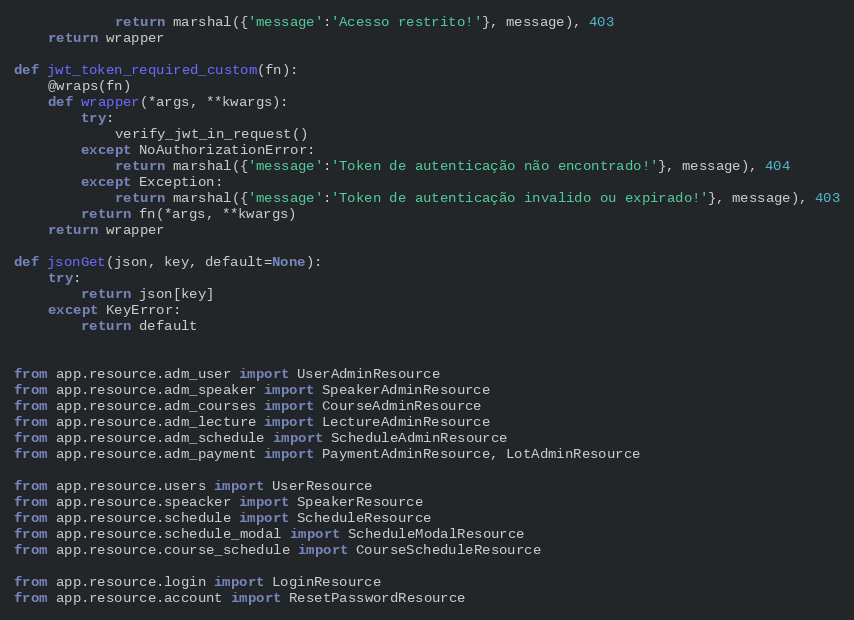<code> <loc_0><loc_0><loc_500><loc_500><_Python_>            return marshal({'message':'Acesso restrito!'}, message), 403
    return wrapper

def jwt_token_required_custom(fn):
    @wraps(fn)
    def wrapper(*args, **kwargs):
        try:
            verify_jwt_in_request()
        except NoAuthorizationError:
            return marshal({'message':'Token de autenticação não encontrado!'}, message), 404
        except Exception:
            return marshal({'message':'Token de autenticação invalido ou expirado!'}, message), 403
        return fn(*args, **kwargs)
    return wrapper

def jsonGet(json, key, default=None):
    try:
        return json[key]
    except KeyError:
        return default


from app.resource.adm_user import UserAdminResource
from app.resource.adm_speaker import SpeakerAdminResource
from app.resource.adm_courses import CourseAdminResource
from app.resource.adm_lecture import LectureAdminResource
from app.resource.adm_schedule import ScheduleAdminResource
from app.resource.adm_payment import PaymentAdminResource, LotAdminResource

from app.resource.users import UserResource
from app.resource.speacker import SpeakerResource
from app.resource.schedule import ScheduleResource
from app.resource.schedule_modal import ScheduleModalResource
from app.resource.course_schedule import CourseScheduleResource

from app.resource.login import LoginResource
from app.resource.account import ResetPasswordResource</code> 